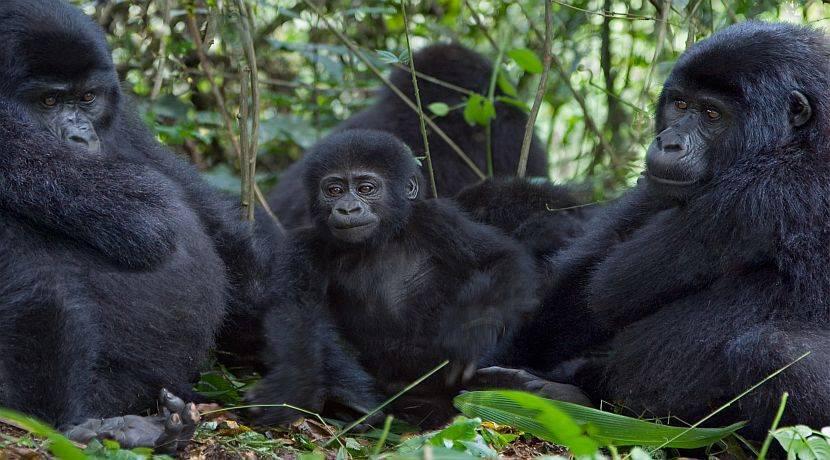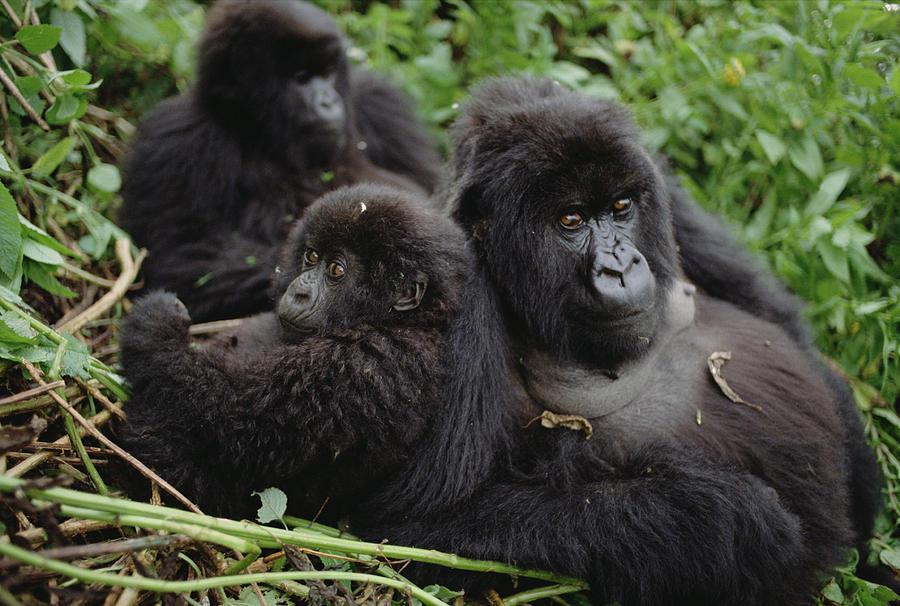The first image is the image on the left, the second image is the image on the right. Given the left and right images, does the statement "The right image includes no more than two apes." hold true? Answer yes or no. No. The first image is the image on the left, the second image is the image on the right. For the images shown, is this caption "Three gorillas sit in the grass in the image on the right." true? Answer yes or no. Yes. 